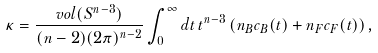<formula> <loc_0><loc_0><loc_500><loc_500>\kappa = \frac { v o l ( S ^ { n - 3 } ) } { ( n - 2 ) ( 2 \pi ) ^ { n - 2 } } \int _ { 0 } ^ { \infty } d t \, t ^ { n - 3 } \, ( n _ { B } c _ { B } ( t ) + n _ { F } c _ { F } ( t ) ) \, ,</formula> 